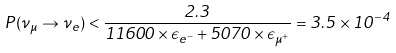<formula> <loc_0><loc_0><loc_500><loc_500>P ( \nu _ { \mu } \rightarrow \nu _ { e } ) < \frac { 2 . 3 } { 1 1 6 0 0 \times \epsilon _ { e ^ { - } } + 5 0 7 0 \times \epsilon _ { \mu ^ { + } } } = 3 . 5 \times 1 0 ^ { - 4 }</formula> 